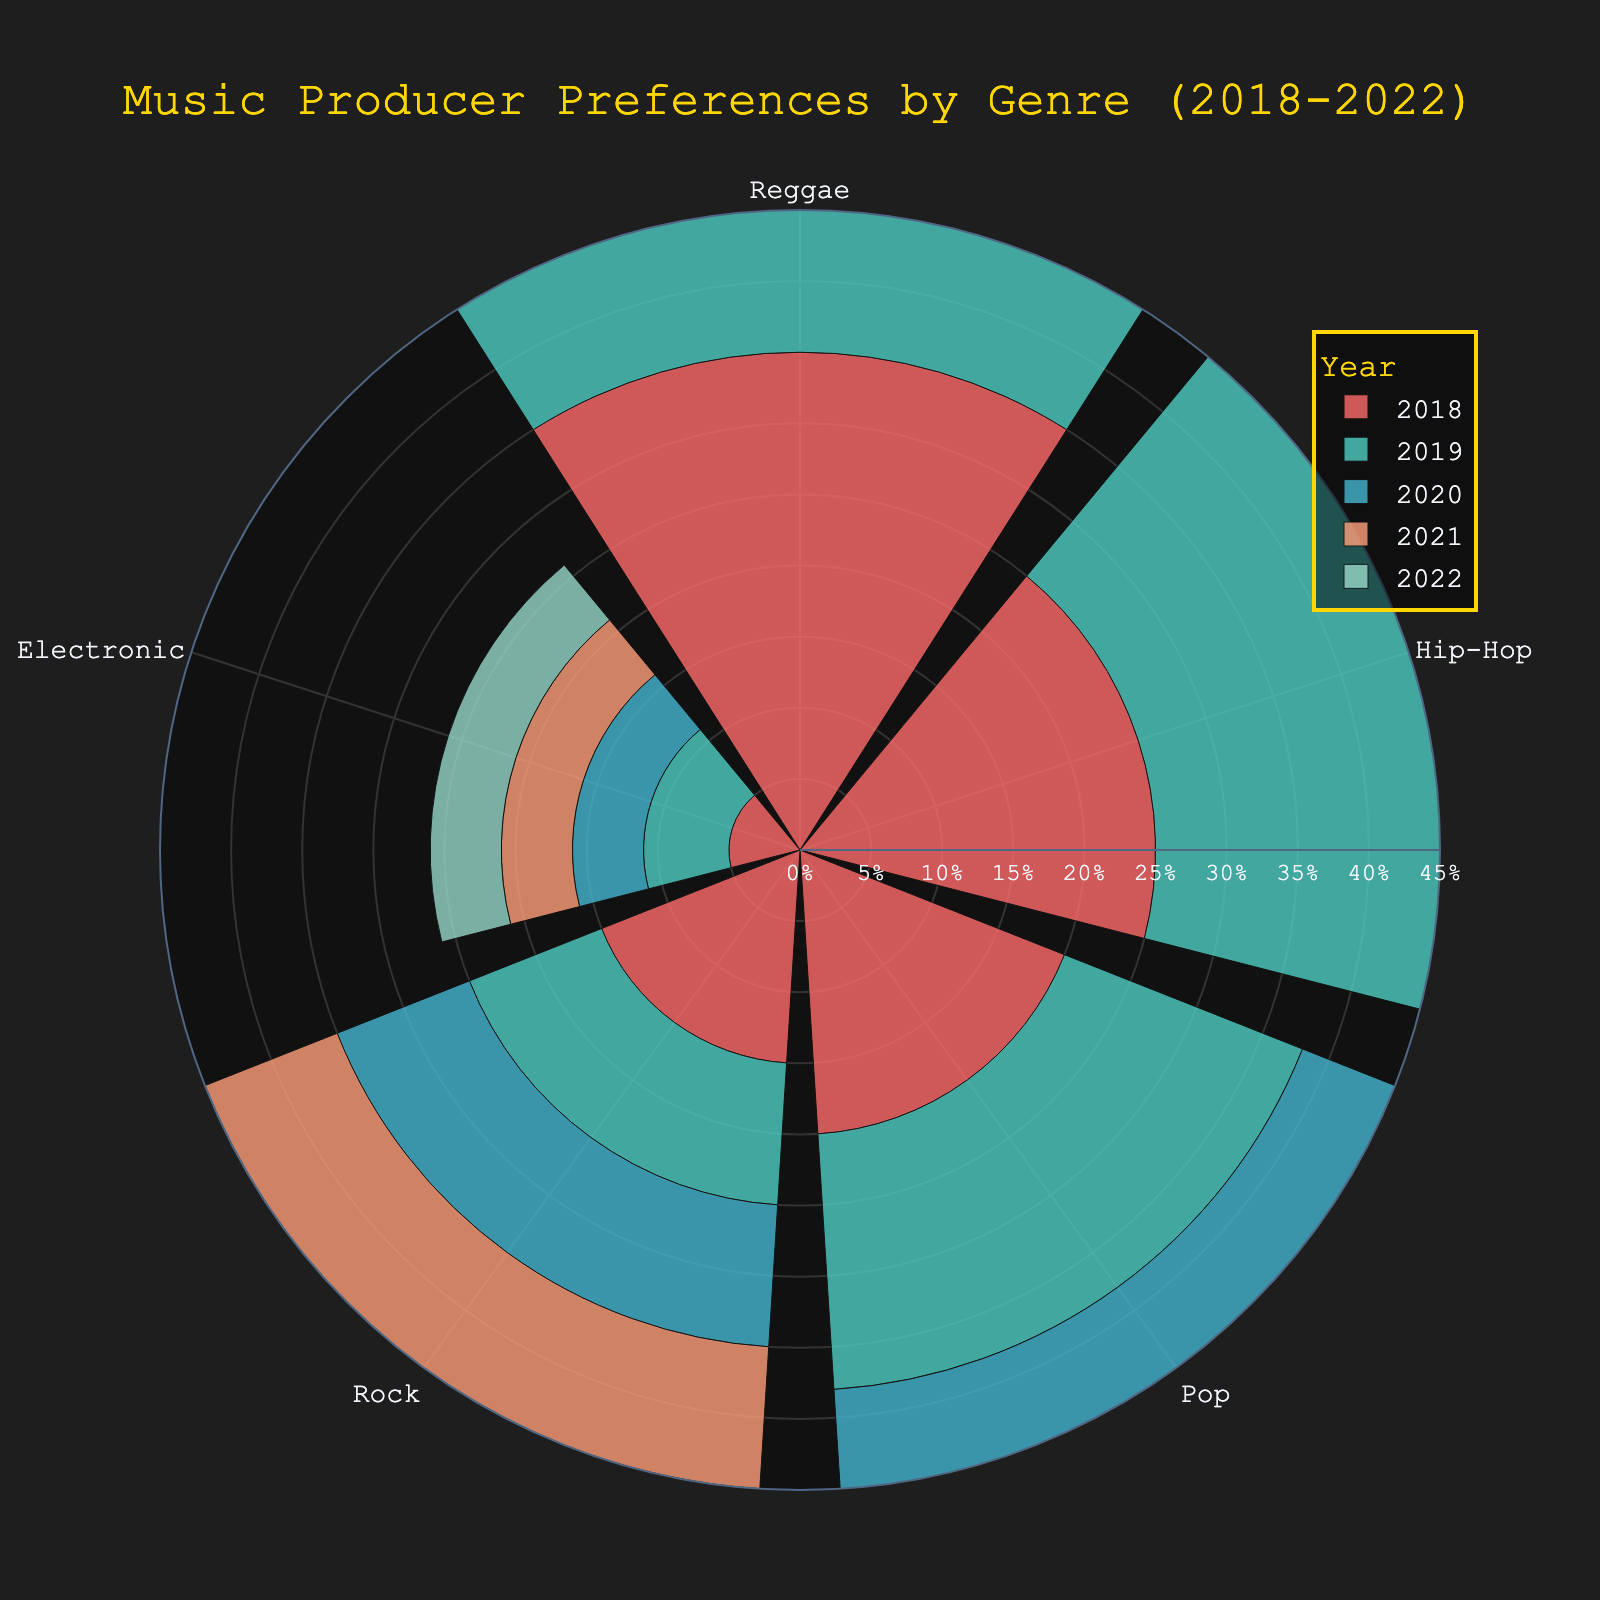What is the title of the figure? The title of the figure is usually located at the top and is clearly marked in the layout. In this case, it states the main subject of the visual representation.
Answer: Music Producer Preferences by Genre (2018-2022) Which genre did DJ Khaled primarily produce in 2020? By looking at the segment associated with DJ Khaled in the bar polar plot for the year 2020, we see that his largest portion is for the genre Reggae.
Answer: Reggae Which year had the lowest percentage for Dave Cobb producing rock music? By comparing all the radial bars for Dave Cobb from 2018 to 2022, we observe that 2019 had the lowest percentage for Dave Cobb producing rock music.
Answer: 2019 How did Dr. Dre's preference for Hip-Hop change from 2018 to 2022? Observing the percentage of Hip-Hop in Dr. Dre's bars from 2018 to 2022, we see the values for each year are: 25%, 28%, 30%, 28%, 30%. The preference increased overall with minor fluctuations.
Answer: Increased overall What was the total percentage of genres produced by Max Martin in 2018? Max Martin's percentage in 2018 for Pop was 20%. Since this was the only genre he produced, the total is simply 20%.
Answer: 20% Compare DJ Khaled's interest in producing Reggae music in 2018 versus 2021. Which year had a higher percentage? Looking at the radial bars for DJ Khaled in 2018 and 2021, we see the percentages are 35% for 2018 and 37% for 2021. Therefore, 2021 had a higher percentage.
Answer: 2021 What color is used to represent the year 2020? The color code for each year can be identified by observing the plot's legend. We see that 2020 is represented by a specific color.
Answer: Blue (#45B7D1) Which genre saw Calvin Harris showing the most consistent interest across the years? For Calvin Harris, we check the percentages for all genres from 2018 to 2022 and notice that Electronic consistently held around 5-6%.
Answer: Electronic What is the overall trend in DJ Khaled's production of Reggae from 2018 to 2022? DJ Khaled's percentages for Reggae over these years are 35%, 38%, 40%, 37%, and 35%. There is a peak in 2020 followed by a slight decline back to his starting percentage.
Answer: Rises till 2020, then declines How does the percentage of Pop music produced by Max Martin in 2022 compare to 2021? Observing the respective percentages for Pop music in Max Martin's bars, we see 20% in 2021 and 18% in 2022. Hence, the percentage slightly decreased.
Answer: Decreased 